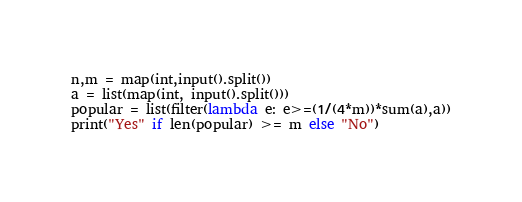<code> <loc_0><loc_0><loc_500><loc_500><_Python_>n,m = map(int,input().split())
a = list(map(int, input().split()))
popular = list(filter(lambda e: e>=(1/(4*m))*sum(a),a))
print("Yes" if len(popular) >= m else "No")</code> 